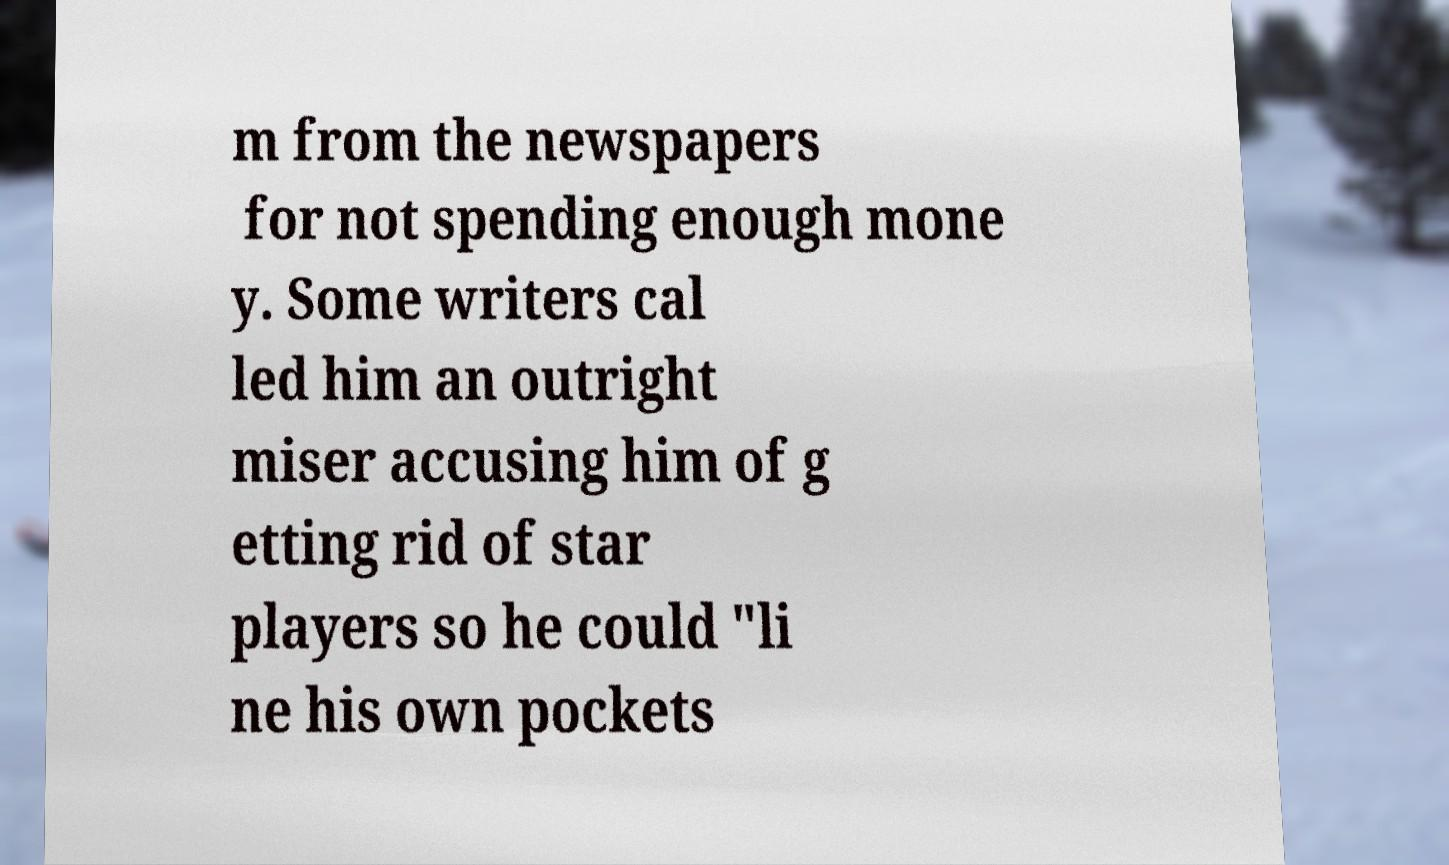I need the written content from this picture converted into text. Can you do that? m from the newspapers for not spending enough mone y. Some writers cal led him an outright miser accusing him of g etting rid of star players so he could "li ne his own pockets 